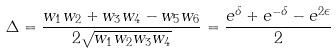<formula> <loc_0><loc_0><loc_500><loc_500>\Delta = \frac { w _ { 1 } w _ { 2 } + w _ { 3 } w _ { 4 } - w _ { 5 } w _ { 6 } } { 2 \sqrt { w _ { 1 } w _ { 2 } w _ { 3 } w _ { 4 } } } = \frac { e ^ { \delta } + e ^ { - \delta } - e ^ { 2 \epsilon } } { 2 }</formula> 